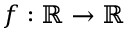<formula> <loc_0><loc_0><loc_500><loc_500>f \colon \mathbb { R } \rightarrow \mathbb { R }</formula> 